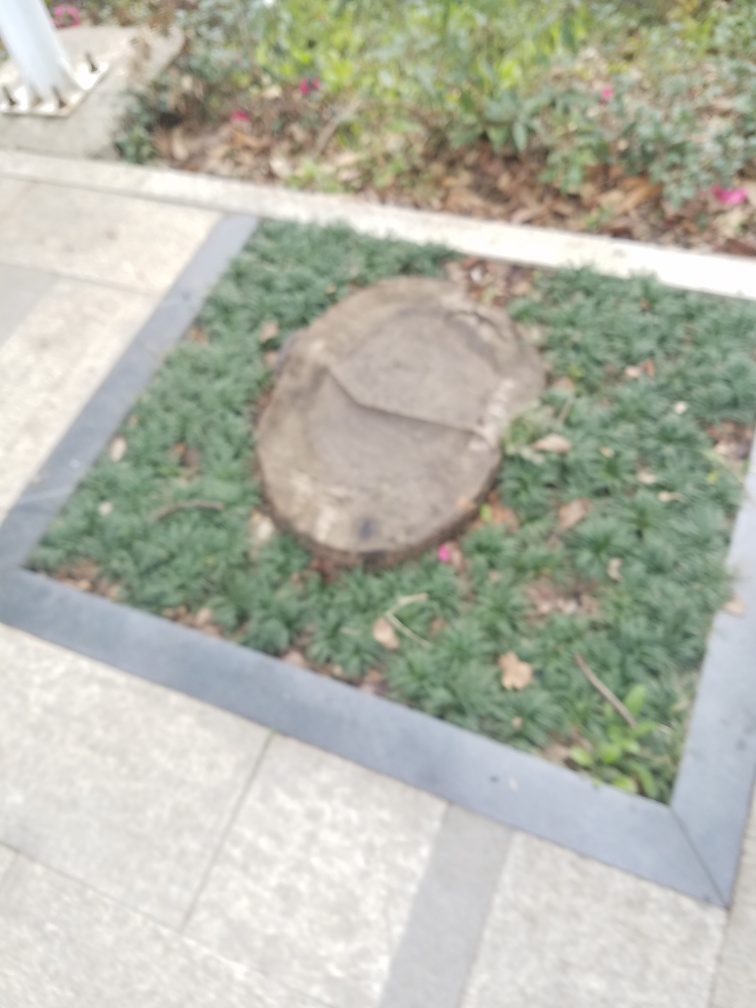What can this image tell us about the location? While specific details are hard to discern due to the blurriness, the presence of the green plants and the landscaping style might suggest an outdoor, possibly public space such as a park or a garden area within an urban setting. 